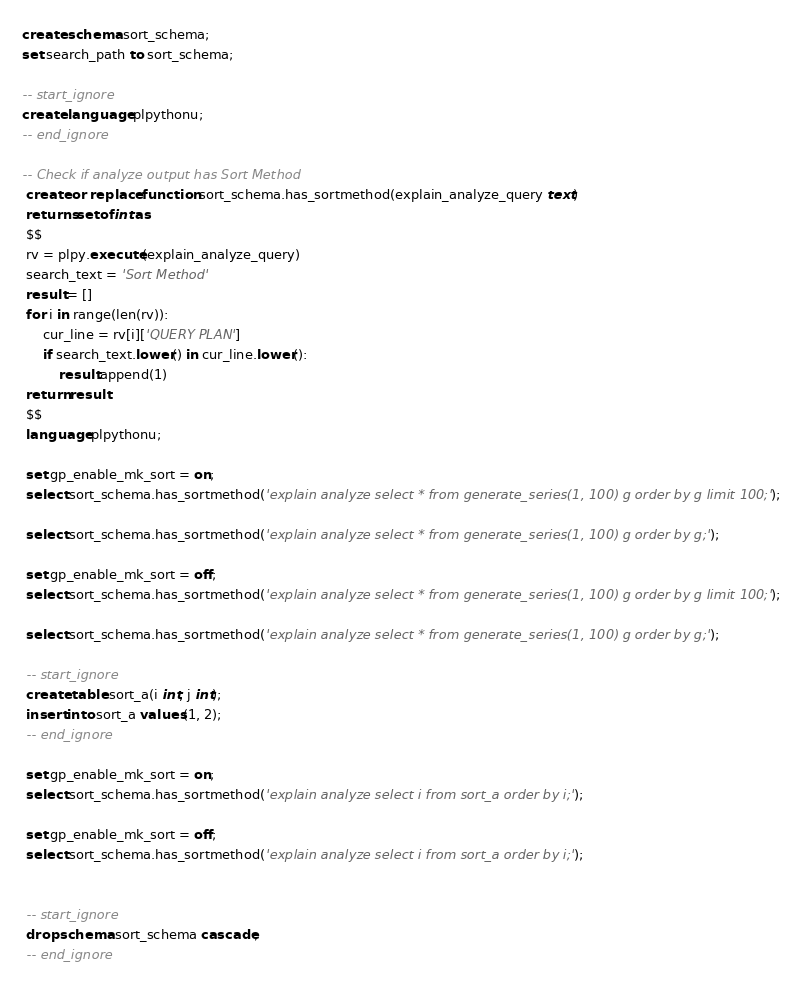Convert code to text. <code><loc_0><loc_0><loc_500><loc_500><_SQL_>create schema sort_schema;
set search_path to sort_schema;
 
-- start_ignore
create language plpythonu;
-- end_ignore
 
-- Check if analyze output has Sort Method
 create or replace function sort_schema.has_sortmethod(explain_analyze_query text)
 returns setof int as
 $$
 rv = plpy.execute(explain_analyze_query)
 search_text = 'Sort Method'
 result = []
 for i in range(len(rv)):
     cur_line = rv[i]['QUERY PLAN']
     if search_text.lower() in cur_line.lower():
         result.append(1)
 return result
 $$
 language plpythonu;
 
 set gp_enable_mk_sort = on;
 select sort_schema.has_sortmethod('explain analyze select * from generate_series(1, 100) g order by g limit 100;');
 
 select sort_schema.has_sortmethod('explain analyze select * from generate_series(1, 100) g order by g;');
 
 set gp_enable_mk_sort = off;
 select sort_schema.has_sortmethod('explain analyze select * from generate_series(1, 100) g order by g limit 100;');
 
 select sort_schema.has_sortmethod('explain analyze select * from generate_series(1, 100) g order by g;');
 
 -- start_ignore
 create table sort_a(i int, j int);
 insert into sort_a values(1, 2);
 -- end_ignore
 
 set gp_enable_mk_sort = on;
 select sort_schema.has_sortmethod('explain analyze select i from sort_a order by i;');
 
 set gp_enable_mk_sort = off;
 select sort_schema.has_sortmethod('explain analyze select i from sort_a order by i;');
 
 
 -- start_ignore
 drop schema sort_schema cascade;
 -- end_ignore</code> 